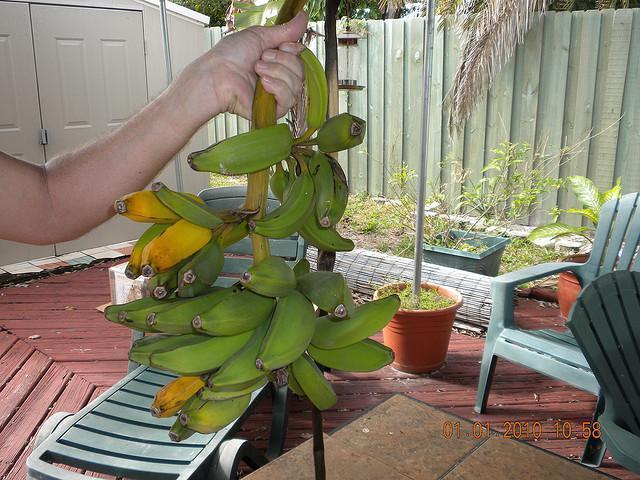Is the statement "The person is touching the banana." accurate regarding the image?
Answer yes or no. Yes. Is the given caption "The banana is in the middle of the person." fitting for the image?
Answer yes or no. No. 